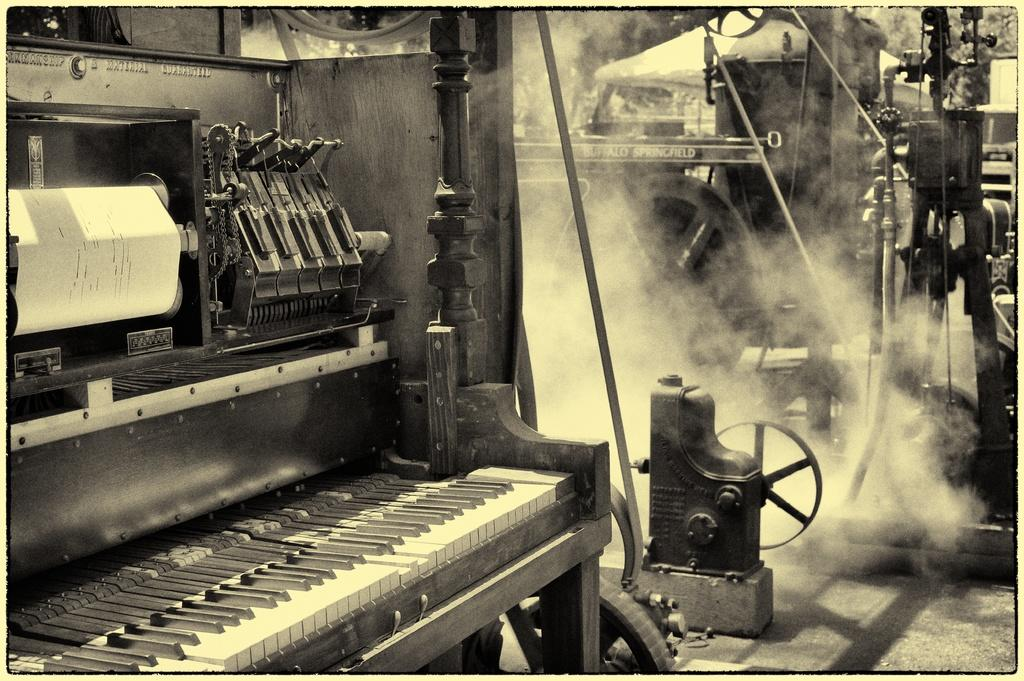What musical instrument is in the image? There is a piano in the image. What else can be seen in the image besides the piano? There are papers visible in the image. What can be seen in the background of the image? There is smoke visible in the background of the image, along with other equipment. What type of string is used to create the harmony in the image? There is no string or harmony present in the image; it features a piano and papers. What texture can be seen on the piano keys in the image? The image does not provide enough detail to determine the texture of the piano keys. 